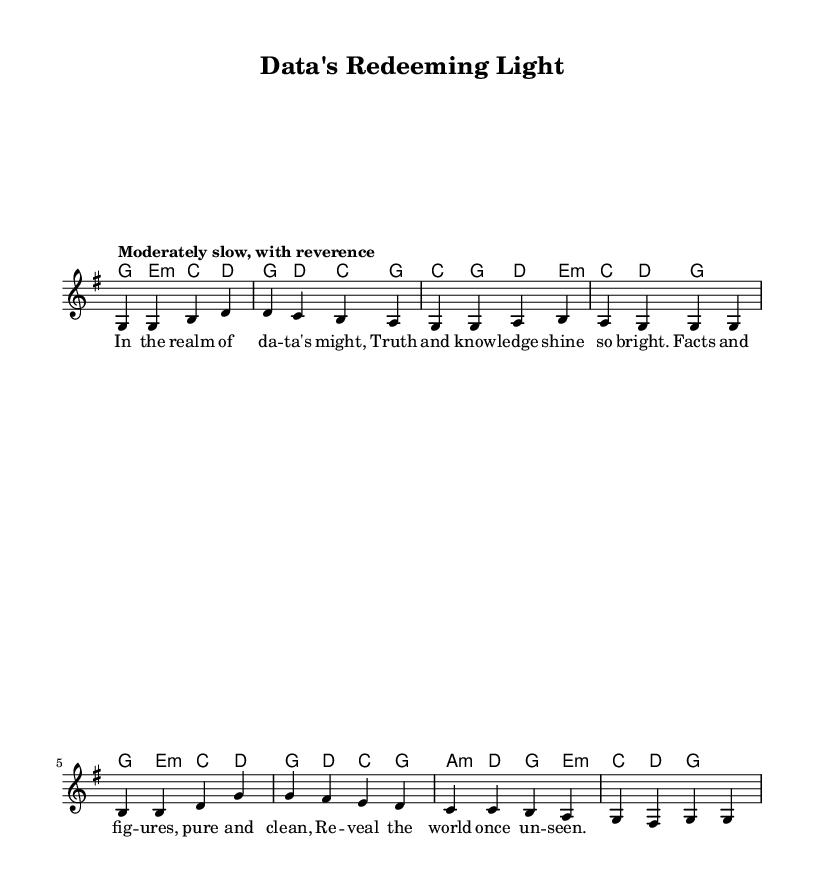What is the key signature of this music? The key signature is G major, which has one sharp (F#). This is visible at the beginning of the sheet music where the key signature is indicated.
Answer: G major What is the time signature of this music? The time signature is 4/4, which is shown at the beginning of the score. This indicates that there are four beats in each measure and a quarter note receives one beat.
Answer: 4/4 What is the tempo marking for this piece? The tempo marking is "Moderately slow, with reverence." This is indicated within the score where it specifies how the piece should be played.
Answer: Moderately slow, with reverence How many measures are in the melody? There are eight measures in the melody, which can be counted by observing the vertical lines that separate the measures. Each set of notes between these lines counts as one measure.
Answer: 8 What is the main theme of the lyrics? The main theme of the lyrics is about the power of data and knowledge bringing truth to light. This can be inferred from lines discussing "truth", "knowledge", and revealing the "world once unseen."
Answer: Power of data and knowledge Do the harmonies change throughout the piece? Yes, the harmonies do change throughout the piece, as indicated by different chords in the chord mode. Each set of chords corresponds to the melody underneath, showing progression.
Answer: Yes What is the overall mood conveyed by the piece? The overall mood is one of reverence and celebration of knowledge, suggested by the tempo and the content of the lyrics that emphasize enlightenment through data.
Answer: Reverence 